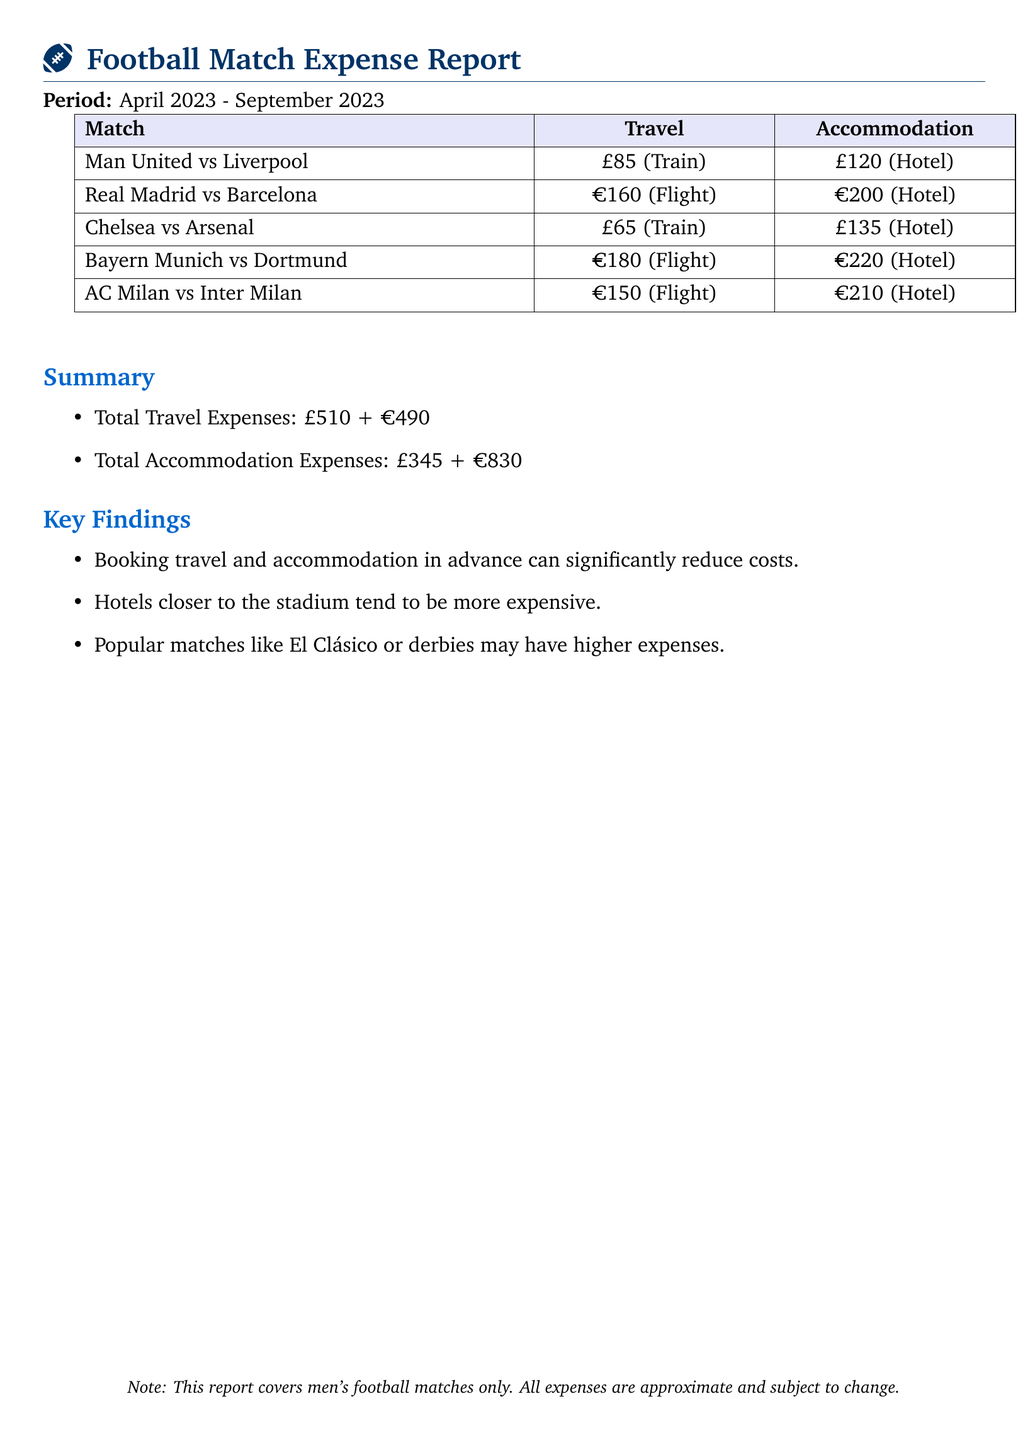What is the total travel expense? The total travel expense is obtained by adding all travel expenses for matches listed in the table, which is £510 + €490.
Answer: £510 + €490 What was the accommodation cost for the match between Bayern Munich and Dortmund? The accommodation cost for this match is specified in the table, which is €220 (Hotel).
Answer: €220 How many matches are listed in the report? The report includes all matches listed in the table, which totals five matches.
Answer: 5 What type of matches does this report cover? The report explicitly states that it covers only men's football matches.
Answer: Men's football matches Which match had the highest travel expense? The maximum travel expense listed is for the match Real Madrid vs Barcelona, which is €160 (Flight).
Answer: €160 What is the total accommodation expense in euros? The total accommodation expense in euros is calculated by summing all relevant accommodation expenses, which is €830.
Answer: €830 Which match's accommodation was the cheapest? By inspecting the accommodation expenses in the table, the cheapest is from Chelsea vs Arsenal at £135.
Answer: £135 What does the report suggest about booking accommodations? The report mentions that booking in advance can reduce costs significantly, indicating a general strategy for expense management.
Answer: Reduce costs significantly 